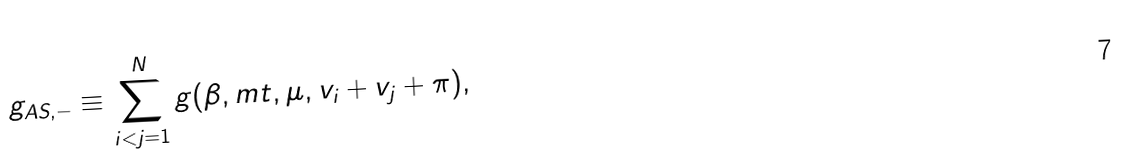Convert formula to latex. <formula><loc_0><loc_0><loc_500><loc_500>g _ { A S , - } \equiv \sum _ { i < j = 1 } ^ { N } g ( \beta , m t , \mu , v _ { i } + v _ { j } + \pi ) ,</formula> 